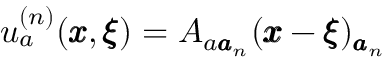Convert formula to latex. <formula><loc_0><loc_0><loc_500><loc_500>u _ { a } ^ { ( n ) } ( { \pm b x } , { \pm b \xi } ) = A _ { { a } { \pm b a } _ { n } } ( { \pm b x } - { \pm b \xi } ) _ { { \pm b a } _ { n } }</formula> 